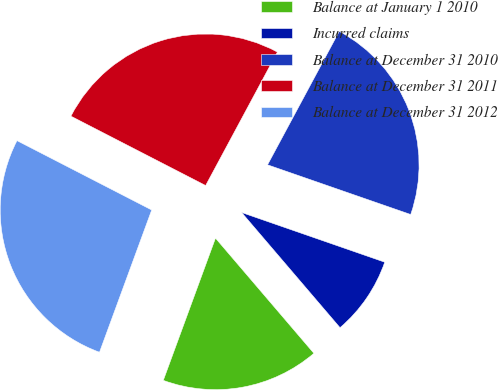Convert chart to OTSL. <chart><loc_0><loc_0><loc_500><loc_500><pie_chart><fcel>Balance at January 1 2010<fcel>Incurred claims<fcel>Balance at December 31 2010<fcel>Balance at December 31 2011<fcel>Balance at December 31 2012<nl><fcel>16.85%<fcel>8.43%<fcel>22.47%<fcel>25.28%<fcel>26.97%<nl></chart> 